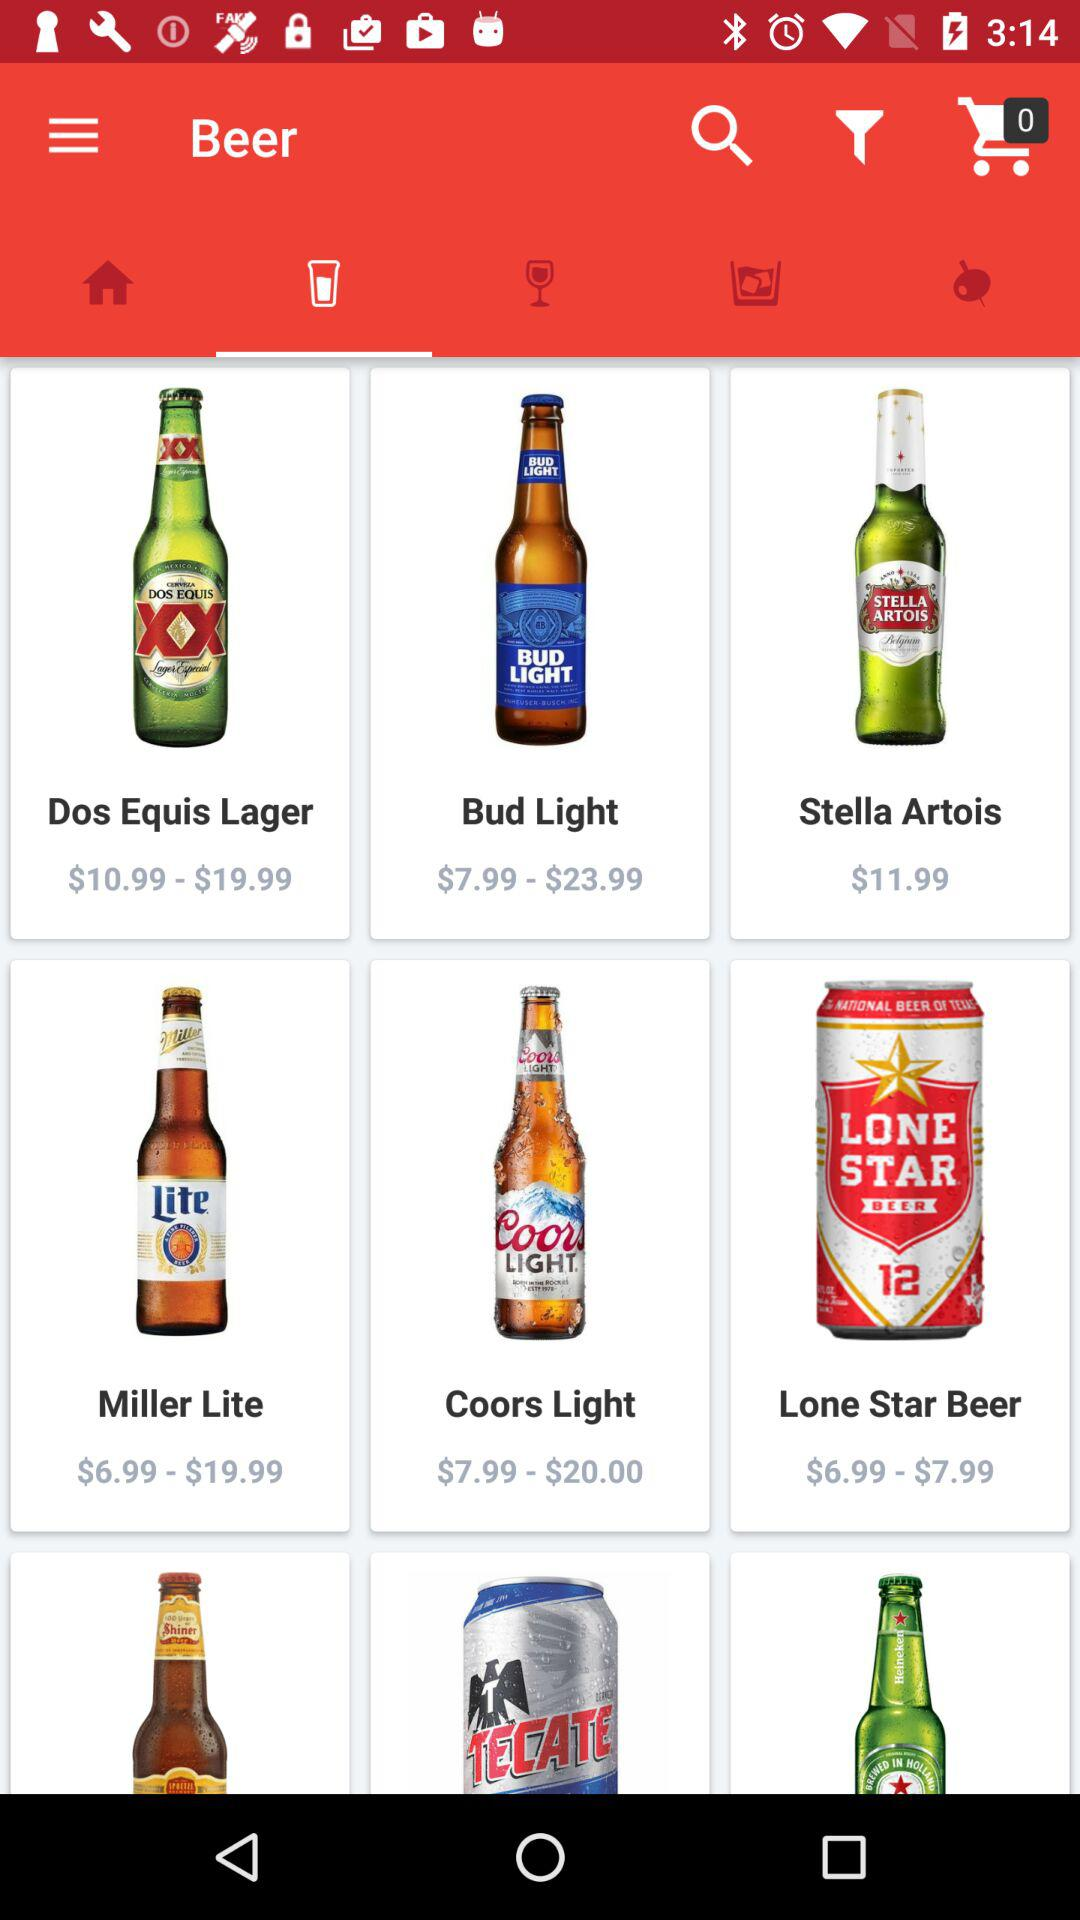What is the price of "Bud Light" beer? The price ranges from $7.99 to $23.99. 